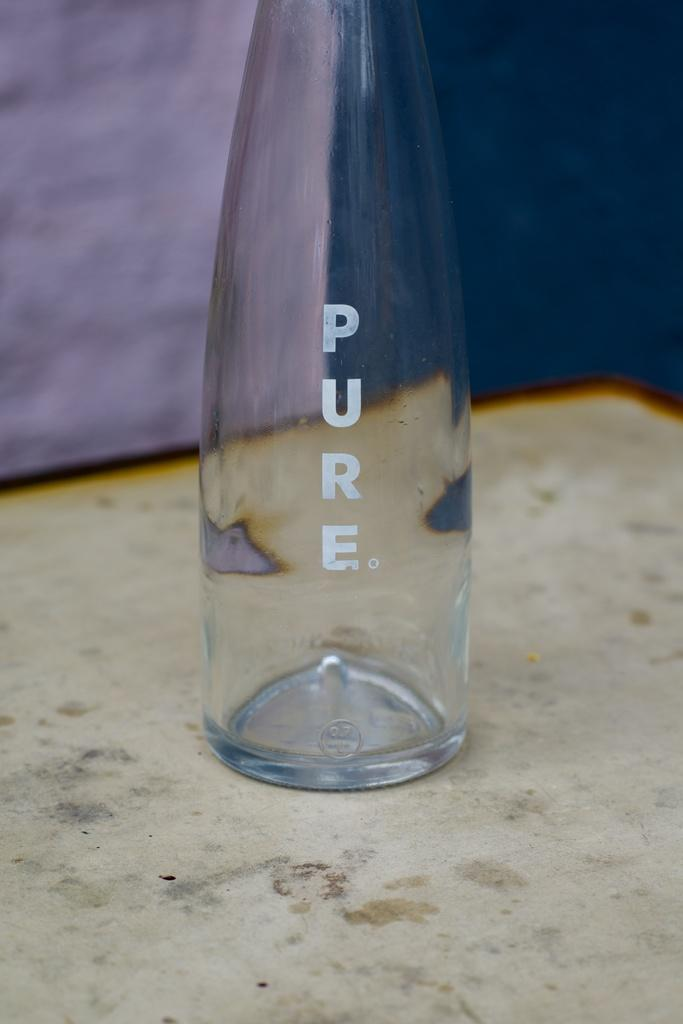What object can be seen on the ground in the image? There is a bottle on the ground in the image. What is the purpose of the text printed on the bottle? The purpose of the text printed on the bottle is not clear from the image alone, but it may contain information about the contents or brand. Can you describe the appearance of the bottle? The bottle is on the ground, and there is text printed on it. How many bees are attempting to copy the text on the bottle in the image? There are no bees present in the image, and therefore no such activity can be observed. 